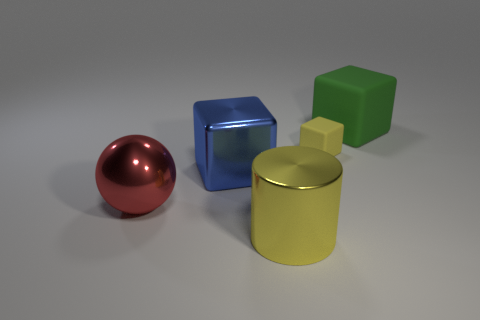How many objects are there in total, and can you describe their colors and materials? The image displays a total of five objects, each with a distinct color and appearance. Starting from the left, there is a red sphere with a reflective surface, suggesting a possibly metallic material. Next, a blue cube, also with a reflective surface, perhaps made of a similar material. Behind the cube is a yellow cylinder with a matte finish that looks more like a plastic material. In front of the cylinder rests a small beige cube, likely made of the same matte plastic. And finally, a green cube to the right, sharing the matte texture, possibly another plastic object. 